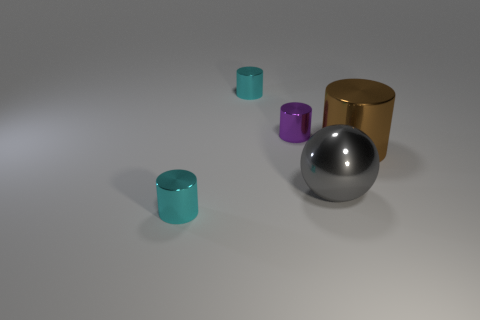There is a large brown thing that is the same shape as the tiny purple shiny object; what is it made of?
Your answer should be compact. Metal. What is the object that is both in front of the purple thing and behind the large metallic ball made of?
Give a very brief answer. Metal. There is a metallic object that is both behind the sphere and in front of the small purple metallic object; how big is it?
Provide a short and direct response. Large. There is a object that is to the right of the tiny purple shiny cylinder and in front of the big brown shiny thing; what color is it?
Make the answer very short. Gray. What is the material of the cyan cylinder behind the purple metallic object?
Your response must be concise. Metal. How big is the purple shiny cylinder?
Offer a terse response. Small. What number of gray things are either small things or large metal balls?
Your answer should be compact. 1. There is a gray metal sphere that is behind the cylinder that is in front of the gray thing; how big is it?
Keep it short and to the point. Large. What number of other objects are the same material as the purple cylinder?
Give a very brief answer. 4. There is a purple thing that is the same material as the large brown cylinder; what is its shape?
Keep it short and to the point. Cylinder. 